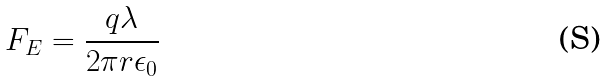Convert formula to latex. <formula><loc_0><loc_0><loc_500><loc_500>F _ { E } = \frac { q \lambda } { 2 \pi r \epsilon _ { 0 } }</formula> 